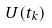<formula> <loc_0><loc_0><loc_500><loc_500>U ( t _ { k } )</formula> 